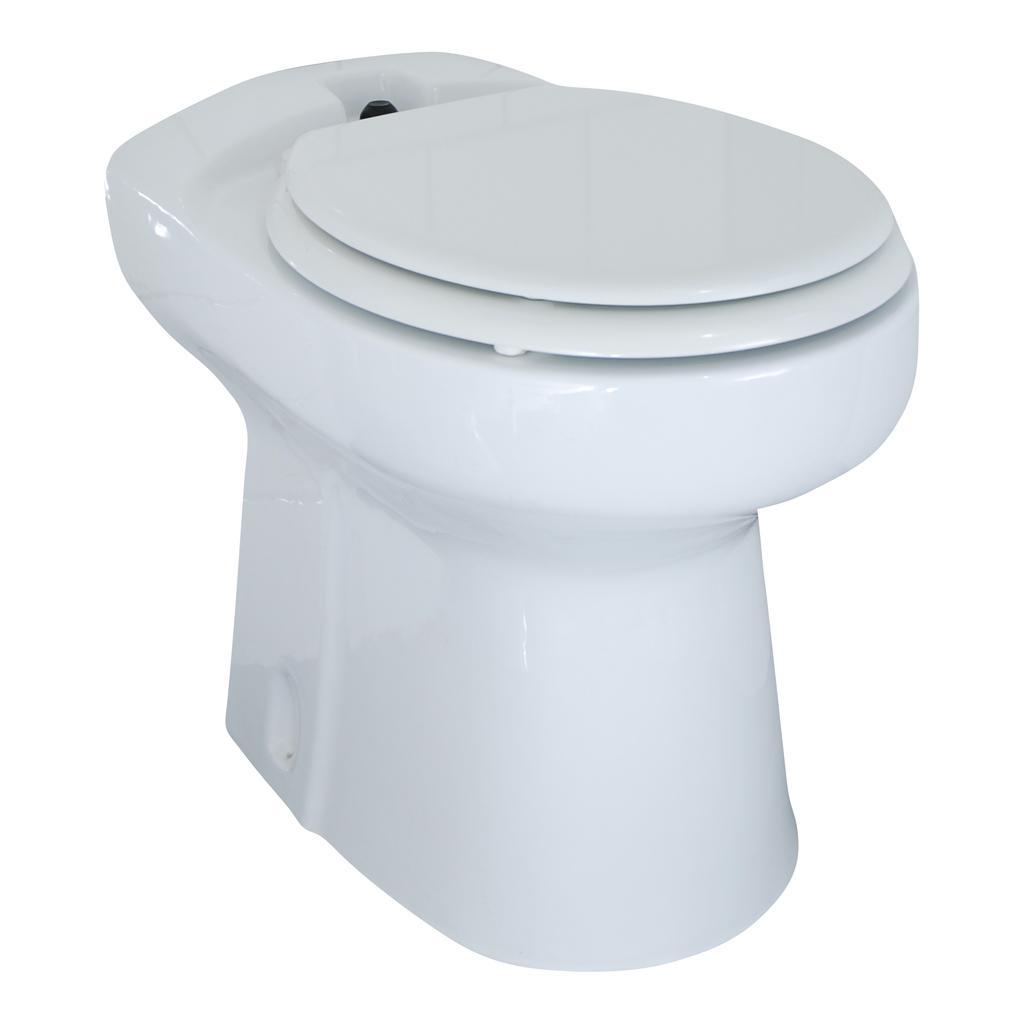Please provide a concise description of this image. In this image, we can see a western toilet and there is a white background. 